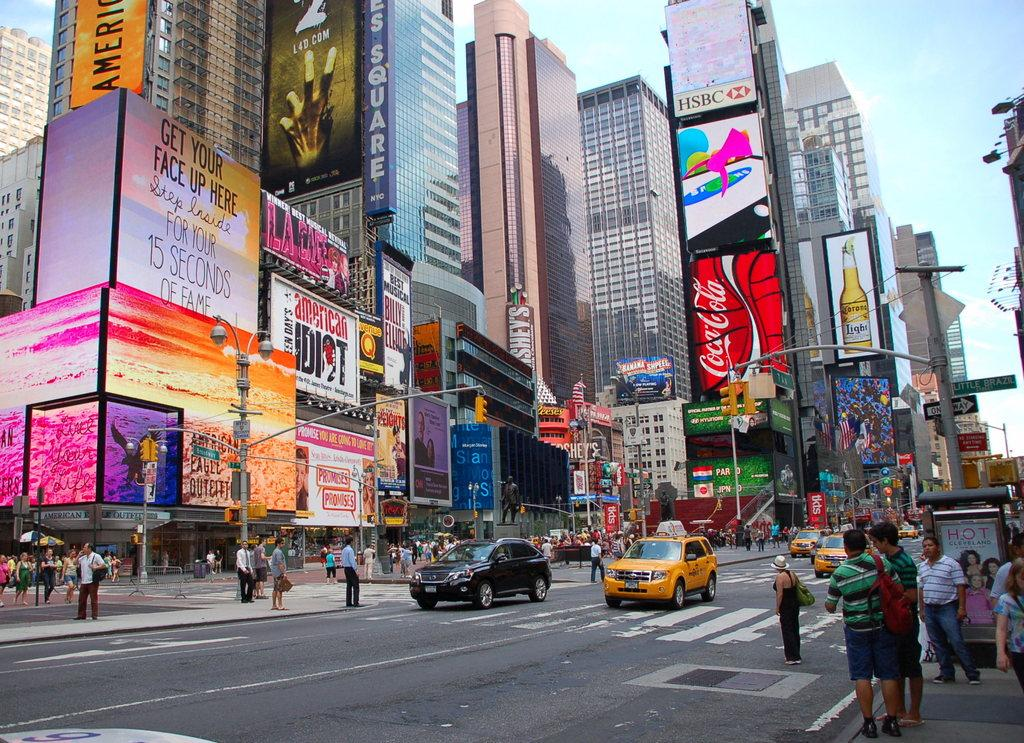<image>
Create a compact narrative representing the image presented. Pedestrians are waiting to cross a busy intersection in a shopping plaza with signs for Coca-Cola. 